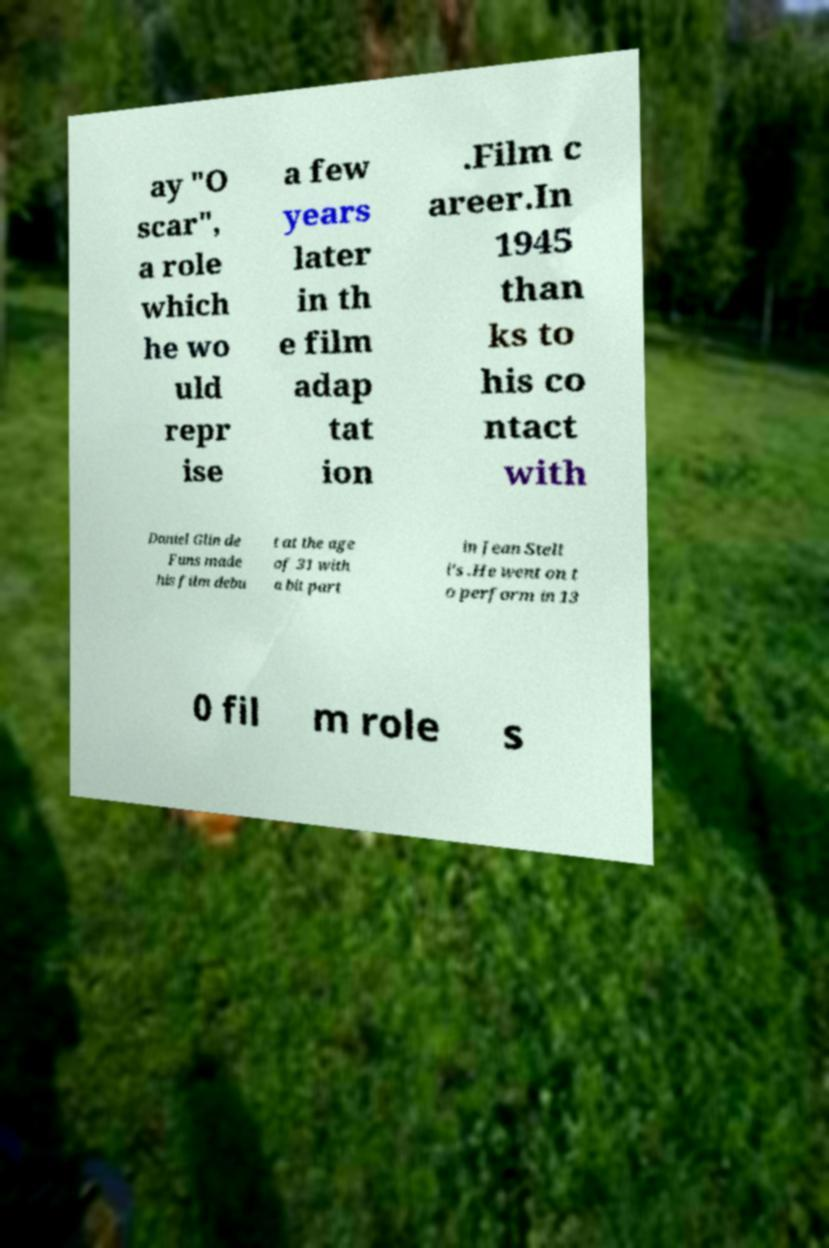Could you assist in decoding the text presented in this image and type it out clearly? ay "O scar", a role which he wo uld repr ise a few years later in th e film adap tat ion .Film c areer.In 1945 than ks to his co ntact with Daniel Glin de Funs made his film debu t at the age of 31 with a bit part in Jean Stell i's .He went on t o perform in 13 0 fil m role s 